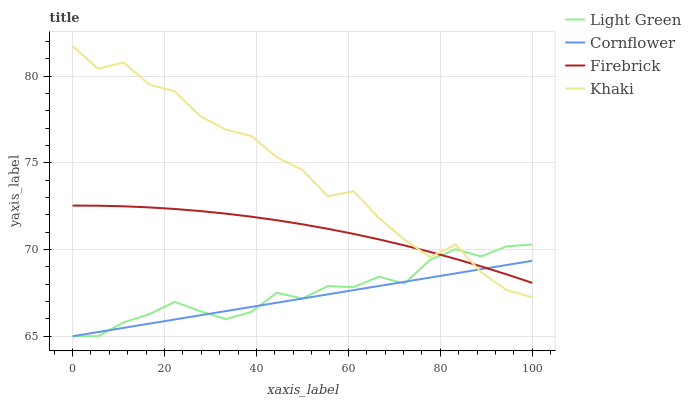Does Cornflower have the minimum area under the curve?
Answer yes or no. Yes. Does Khaki have the maximum area under the curve?
Answer yes or no. Yes. Does Firebrick have the minimum area under the curve?
Answer yes or no. No. Does Firebrick have the maximum area under the curve?
Answer yes or no. No. Is Cornflower the smoothest?
Answer yes or no. Yes. Is Khaki the roughest?
Answer yes or no. Yes. Is Firebrick the smoothest?
Answer yes or no. No. Is Firebrick the roughest?
Answer yes or no. No. Does Cornflower have the lowest value?
Answer yes or no. Yes. Does Khaki have the lowest value?
Answer yes or no. No. Does Khaki have the highest value?
Answer yes or no. Yes. Does Firebrick have the highest value?
Answer yes or no. No. Does Cornflower intersect Light Green?
Answer yes or no. Yes. Is Cornflower less than Light Green?
Answer yes or no. No. Is Cornflower greater than Light Green?
Answer yes or no. No. 